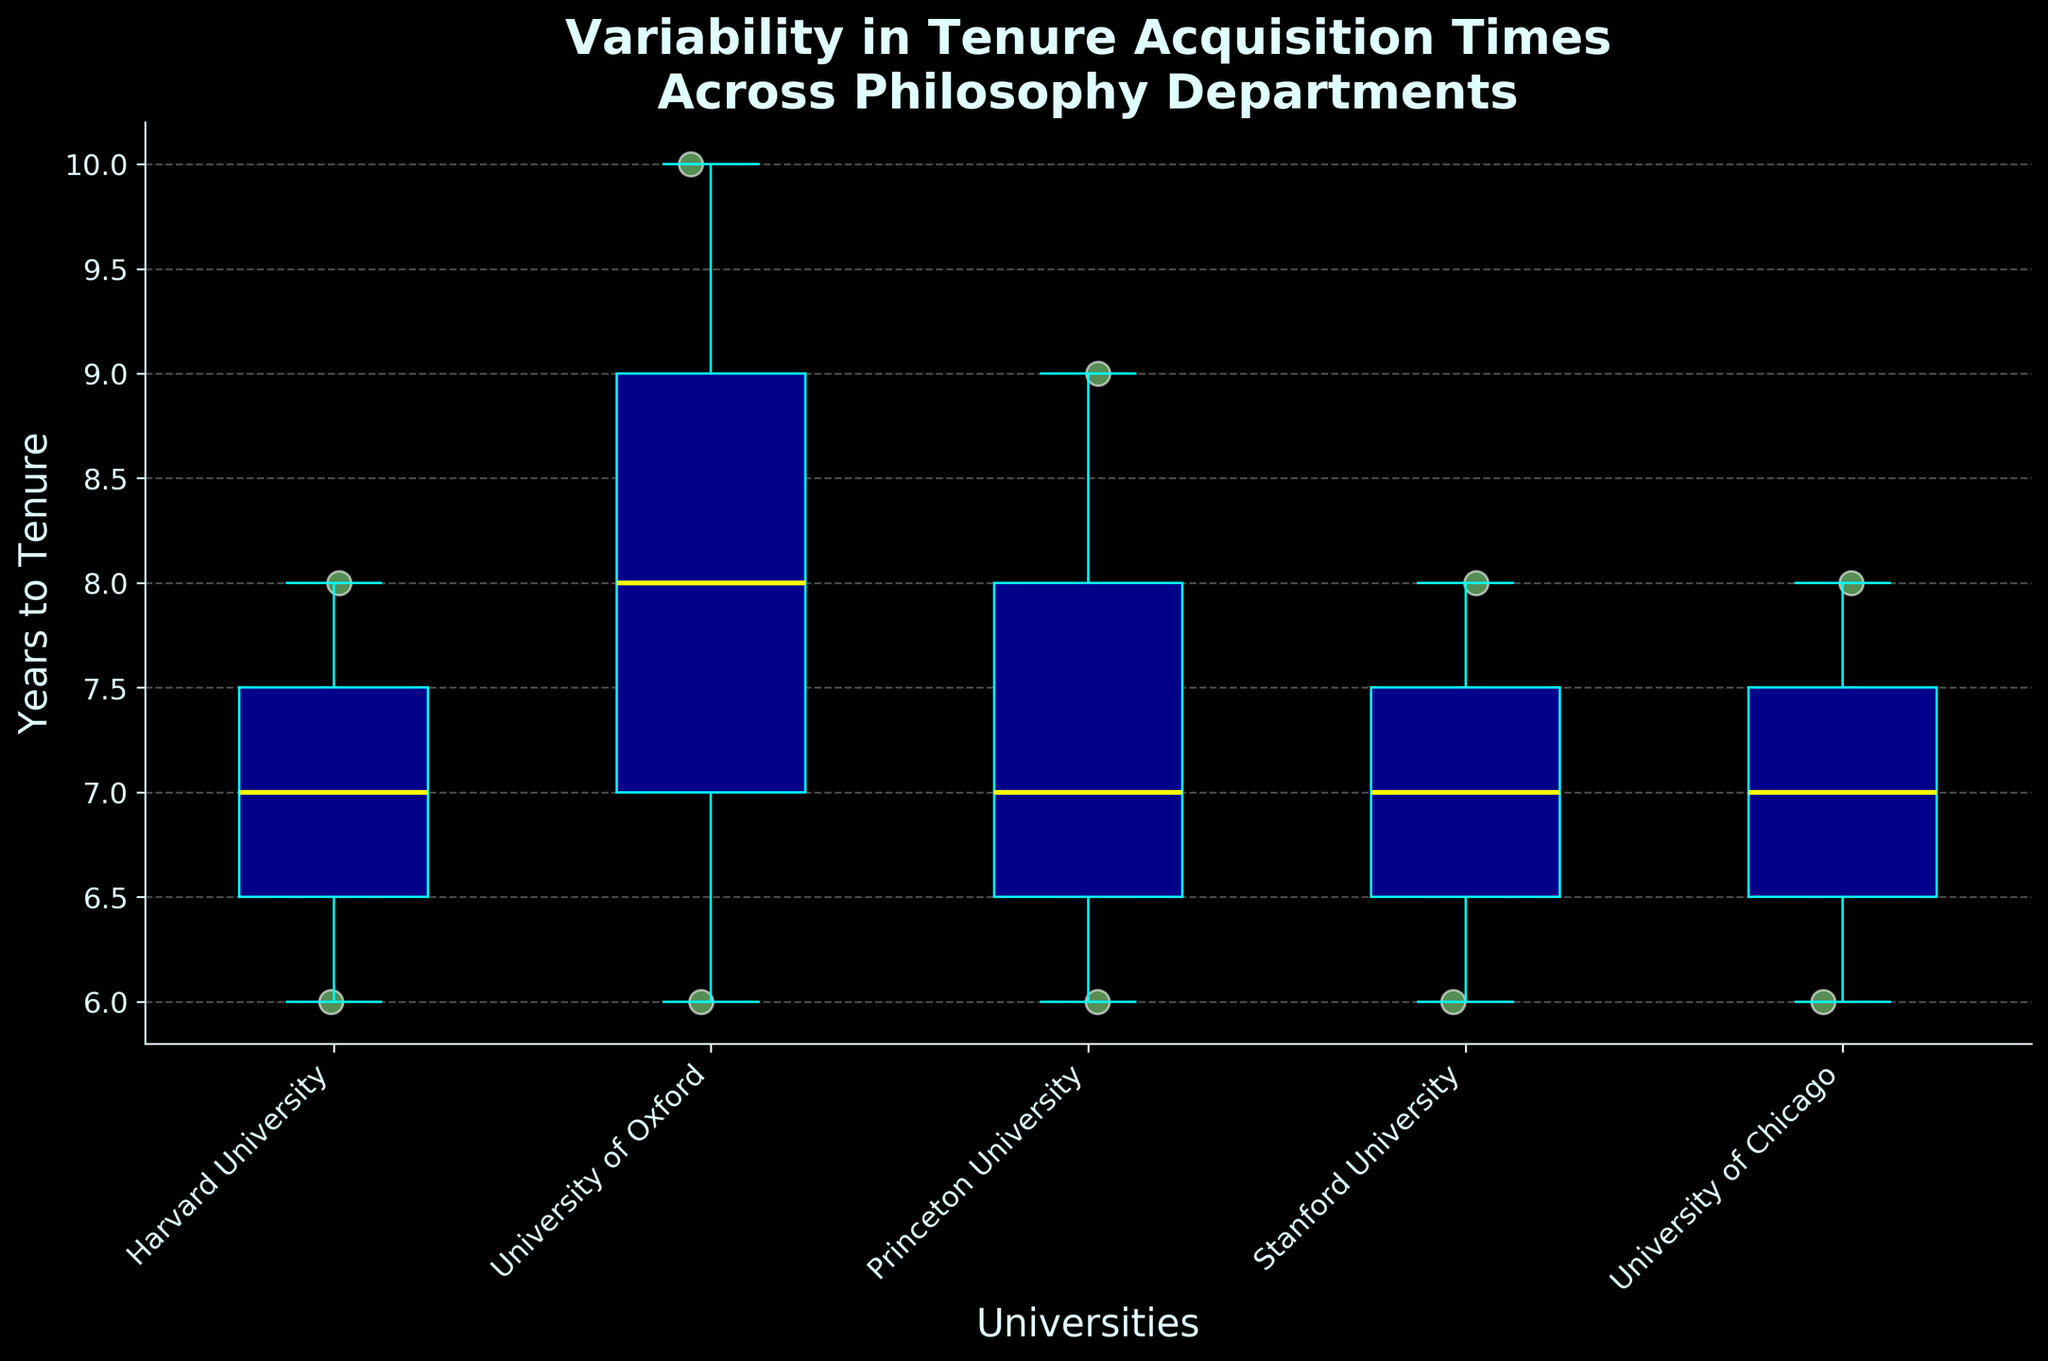What is the title of the plot? The title is typically found at the top of the plot in larger text. Here, it reads "Variability in Tenure Acquisition Times Across Philosophy Departments".
Answer: Variability in Tenure Acquisition Times Across Philosophy Departments Which university has the highest maximum tenure acquisition time? Look at the top whisker or scatter points of each university's box plot. The one with the highest point represents the maximum tenure time.
Answer: University of Oxford What's the median tenure acquisition time at Harvard University? The median is indicated by the yellow line inside the box plot. For Harvard, this line appears around 7 years.
Answer: 7 years How many individual tenure acquisition times are displayed for Stanford University? Count the number of light green scatter points over the "Stanford University" box plot. There are 3 points visible.
Answer: 3 Which university shows the least variability in tenure acquisition times? Variability can be assessed by looking at the length of the boxes (IQR) and whiskers. The University of Chicago seems to have the shortest box and whiskers.
Answer: University of Chicago What is the range of tenure acquisition times at Princeton University? To find the range, identify the highest and lowest points within Princeton's box plot. The highest (top whisker/scatter point) is 9 years and the lowest (bottom whisker/scatter point) is 6 years. The range is 9 - 6 = 3 years.
Answer: 3 years Which university has the most consistent tenure acquisition times? Consistency can be gauged by the shortest IQR (box length) and whiskers. The University of Chicago displays the smallest spread, suggesting the most consistent times.
Answer: University of Chicago Is there any university where the shortest tenure duration is equal to the longest tenure duration at another university? Compare the minimum whisker or scatter point of each university to the maximum whisker or scatter point of others. Stanford University’s lowest tenure duration (6 years) is equal to Harvard’s maximum tenure duration (6 years).
Answer: Yes How does the median tenure acquisition time at the University of Oxford compare to that at Princeton University? Look at the median lines in the box plots for both universities. The median for Oxford is around 8 years, whereas for Princeton it is around 7 years. Oxford’s median is higher.
Answer: Oxford is higher 